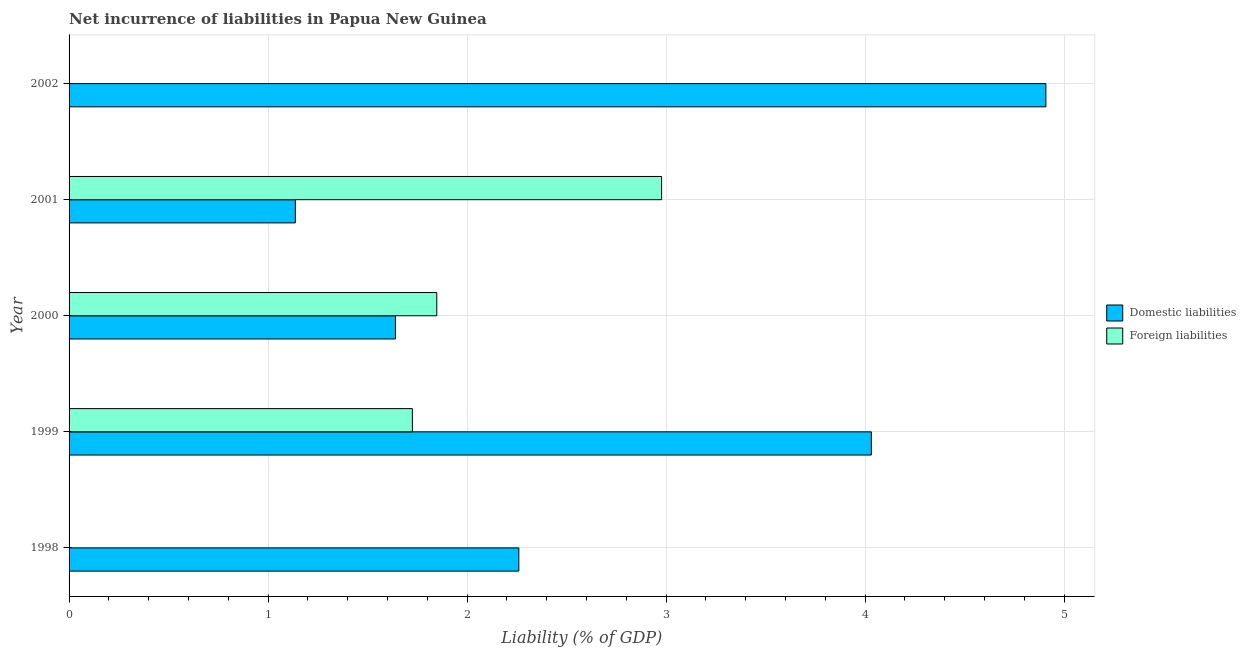How many different coloured bars are there?
Your response must be concise. 2. Are the number of bars on each tick of the Y-axis equal?
Your answer should be compact. No. What is the label of the 2nd group of bars from the top?
Give a very brief answer. 2001. What is the incurrence of domestic liabilities in 1999?
Keep it short and to the point. 4.03. Across all years, what is the maximum incurrence of foreign liabilities?
Offer a very short reply. 2.98. Across all years, what is the minimum incurrence of domestic liabilities?
Keep it short and to the point. 1.14. In which year was the incurrence of domestic liabilities maximum?
Your response must be concise. 2002. What is the total incurrence of domestic liabilities in the graph?
Your answer should be very brief. 13.98. What is the difference between the incurrence of domestic liabilities in 1999 and that in 2000?
Ensure brevity in your answer.  2.39. What is the difference between the incurrence of domestic liabilities in 2002 and the incurrence of foreign liabilities in 1999?
Your answer should be compact. 3.18. What is the average incurrence of foreign liabilities per year?
Your response must be concise. 1.31. In the year 1999, what is the difference between the incurrence of domestic liabilities and incurrence of foreign liabilities?
Give a very brief answer. 2.31. In how many years, is the incurrence of foreign liabilities greater than 1.4 %?
Your answer should be compact. 3. What is the ratio of the incurrence of foreign liabilities in 2000 to that in 2001?
Your answer should be compact. 0.62. Is the incurrence of foreign liabilities in 1999 less than that in 2000?
Keep it short and to the point. Yes. Is the difference between the incurrence of domestic liabilities in 1999 and 2000 greater than the difference between the incurrence of foreign liabilities in 1999 and 2000?
Your response must be concise. Yes. What is the difference between the highest and the second highest incurrence of domestic liabilities?
Give a very brief answer. 0.88. What is the difference between the highest and the lowest incurrence of foreign liabilities?
Ensure brevity in your answer.  2.98. In how many years, is the incurrence of domestic liabilities greater than the average incurrence of domestic liabilities taken over all years?
Keep it short and to the point. 2. Are all the bars in the graph horizontal?
Your response must be concise. Yes. How many years are there in the graph?
Offer a very short reply. 5. What is the difference between two consecutive major ticks on the X-axis?
Your answer should be very brief. 1. Are the values on the major ticks of X-axis written in scientific E-notation?
Provide a succinct answer. No. Does the graph contain grids?
Offer a very short reply. Yes. Where does the legend appear in the graph?
Make the answer very short. Center right. How many legend labels are there?
Keep it short and to the point. 2. How are the legend labels stacked?
Provide a short and direct response. Vertical. What is the title of the graph?
Provide a succinct answer. Net incurrence of liabilities in Papua New Guinea. What is the label or title of the X-axis?
Your answer should be very brief. Liability (% of GDP). What is the label or title of the Y-axis?
Give a very brief answer. Year. What is the Liability (% of GDP) in Domestic liabilities in 1998?
Offer a terse response. 2.26. What is the Liability (% of GDP) in Domestic liabilities in 1999?
Make the answer very short. 4.03. What is the Liability (% of GDP) of Foreign liabilities in 1999?
Your response must be concise. 1.73. What is the Liability (% of GDP) in Domestic liabilities in 2000?
Ensure brevity in your answer.  1.64. What is the Liability (% of GDP) of Foreign liabilities in 2000?
Give a very brief answer. 1.85. What is the Liability (% of GDP) in Domestic liabilities in 2001?
Ensure brevity in your answer.  1.14. What is the Liability (% of GDP) in Foreign liabilities in 2001?
Offer a very short reply. 2.98. What is the Liability (% of GDP) in Domestic liabilities in 2002?
Offer a very short reply. 4.91. Across all years, what is the maximum Liability (% of GDP) in Domestic liabilities?
Provide a short and direct response. 4.91. Across all years, what is the maximum Liability (% of GDP) of Foreign liabilities?
Ensure brevity in your answer.  2.98. Across all years, what is the minimum Liability (% of GDP) in Domestic liabilities?
Provide a succinct answer. 1.14. Across all years, what is the minimum Liability (% of GDP) of Foreign liabilities?
Keep it short and to the point. 0. What is the total Liability (% of GDP) of Domestic liabilities in the graph?
Provide a short and direct response. 13.98. What is the total Liability (% of GDP) of Foreign liabilities in the graph?
Make the answer very short. 6.55. What is the difference between the Liability (% of GDP) in Domestic liabilities in 1998 and that in 1999?
Your answer should be compact. -1.77. What is the difference between the Liability (% of GDP) of Domestic liabilities in 1998 and that in 2000?
Your answer should be compact. 0.62. What is the difference between the Liability (% of GDP) of Domestic liabilities in 1998 and that in 2001?
Offer a terse response. 1.12. What is the difference between the Liability (% of GDP) in Domestic liabilities in 1998 and that in 2002?
Give a very brief answer. -2.65. What is the difference between the Liability (% of GDP) of Domestic liabilities in 1999 and that in 2000?
Your answer should be compact. 2.39. What is the difference between the Liability (% of GDP) of Foreign liabilities in 1999 and that in 2000?
Offer a terse response. -0.12. What is the difference between the Liability (% of GDP) in Domestic liabilities in 1999 and that in 2001?
Offer a very short reply. 2.89. What is the difference between the Liability (% of GDP) of Foreign liabilities in 1999 and that in 2001?
Offer a terse response. -1.25. What is the difference between the Liability (% of GDP) in Domestic liabilities in 1999 and that in 2002?
Your answer should be compact. -0.88. What is the difference between the Liability (% of GDP) in Domestic liabilities in 2000 and that in 2001?
Give a very brief answer. 0.5. What is the difference between the Liability (% of GDP) in Foreign liabilities in 2000 and that in 2001?
Make the answer very short. -1.13. What is the difference between the Liability (% of GDP) in Domestic liabilities in 2000 and that in 2002?
Give a very brief answer. -3.27. What is the difference between the Liability (% of GDP) in Domestic liabilities in 2001 and that in 2002?
Keep it short and to the point. -3.77. What is the difference between the Liability (% of GDP) in Domestic liabilities in 1998 and the Liability (% of GDP) in Foreign liabilities in 1999?
Provide a succinct answer. 0.54. What is the difference between the Liability (% of GDP) in Domestic liabilities in 1998 and the Liability (% of GDP) in Foreign liabilities in 2000?
Keep it short and to the point. 0.41. What is the difference between the Liability (% of GDP) in Domestic liabilities in 1998 and the Liability (% of GDP) in Foreign liabilities in 2001?
Make the answer very short. -0.72. What is the difference between the Liability (% of GDP) of Domestic liabilities in 1999 and the Liability (% of GDP) of Foreign liabilities in 2000?
Offer a terse response. 2.18. What is the difference between the Liability (% of GDP) of Domestic liabilities in 1999 and the Liability (% of GDP) of Foreign liabilities in 2001?
Offer a very short reply. 1.05. What is the difference between the Liability (% of GDP) of Domestic liabilities in 2000 and the Liability (% of GDP) of Foreign liabilities in 2001?
Your answer should be compact. -1.34. What is the average Liability (% of GDP) in Domestic liabilities per year?
Make the answer very short. 2.8. What is the average Liability (% of GDP) of Foreign liabilities per year?
Offer a very short reply. 1.31. In the year 1999, what is the difference between the Liability (% of GDP) of Domestic liabilities and Liability (% of GDP) of Foreign liabilities?
Provide a succinct answer. 2.31. In the year 2000, what is the difference between the Liability (% of GDP) in Domestic liabilities and Liability (% of GDP) in Foreign liabilities?
Offer a terse response. -0.21. In the year 2001, what is the difference between the Liability (% of GDP) of Domestic liabilities and Liability (% of GDP) of Foreign liabilities?
Ensure brevity in your answer.  -1.84. What is the ratio of the Liability (% of GDP) in Domestic liabilities in 1998 to that in 1999?
Ensure brevity in your answer.  0.56. What is the ratio of the Liability (% of GDP) in Domestic liabilities in 1998 to that in 2000?
Offer a very short reply. 1.38. What is the ratio of the Liability (% of GDP) of Domestic liabilities in 1998 to that in 2001?
Provide a succinct answer. 1.99. What is the ratio of the Liability (% of GDP) in Domestic liabilities in 1998 to that in 2002?
Keep it short and to the point. 0.46. What is the ratio of the Liability (% of GDP) in Domestic liabilities in 1999 to that in 2000?
Your answer should be compact. 2.46. What is the ratio of the Liability (% of GDP) of Foreign liabilities in 1999 to that in 2000?
Your answer should be very brief. 0.93. What is the ratio of the Liability (% of GDP) in Domestic liabilities in 1999 to that in 2001?
Keep it short and to the point. 3.55. What is the ratio of the Liability (% of GDP) in Foreign liabilities in 1999 to that in 2001?
Offer a terse response. 0.58. What is the ratio of the Liability (% of GDP) of Domestic liabilities in 1999 to that in 2002?
Give a very brief answer. 0.82. What is the ratio of the Liability (% of GDP) of Domestic liabilities in 2000 to that in 2001?
Ensure brevity in your answer.  1.44. What is the ratio of the Liability (% of GDP) of Foreign liabilities in 2000 to that in 2001?
Offer a terse response. 0.62. What is the ratio of the Liability (% of GDP) in Domestic liabilities in 2000 to that in 2002?
Offer a very short reply. 0.33. What is the ratio of the Liability (% of GDP) of Domestic liabilities in 2001 to that in 2002?
Ensure brevity in your answer.  0.23. What is the difference between the highest and the second highest Liability (% of GDP) in Domestic liabilities?
Offer a very short reply. 0.88. What is the difference between the highest and the second highest Liability (% of GDP) of Foreign liabilities?
Offer a terse response. 1.13. What is the difference between the highest and the lowest Liability (% of GDP) of Domestic liabilities?
Your answer should be compact. 3.77. What is the difference between the highest and the lowest Liability (% of GDP) in Foreign liabilities?
Provide a short and direct response. 2.98. 